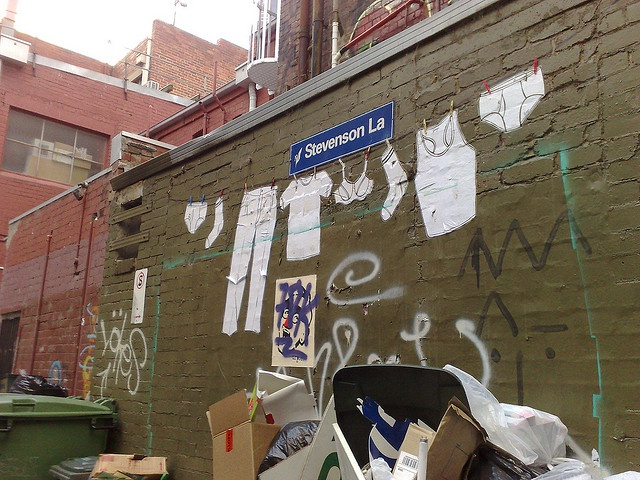Describe the objects in this image and their specific colors. I can see various objects in this image with different colors. 